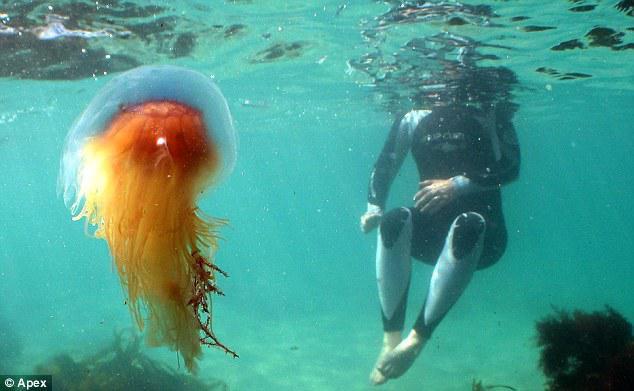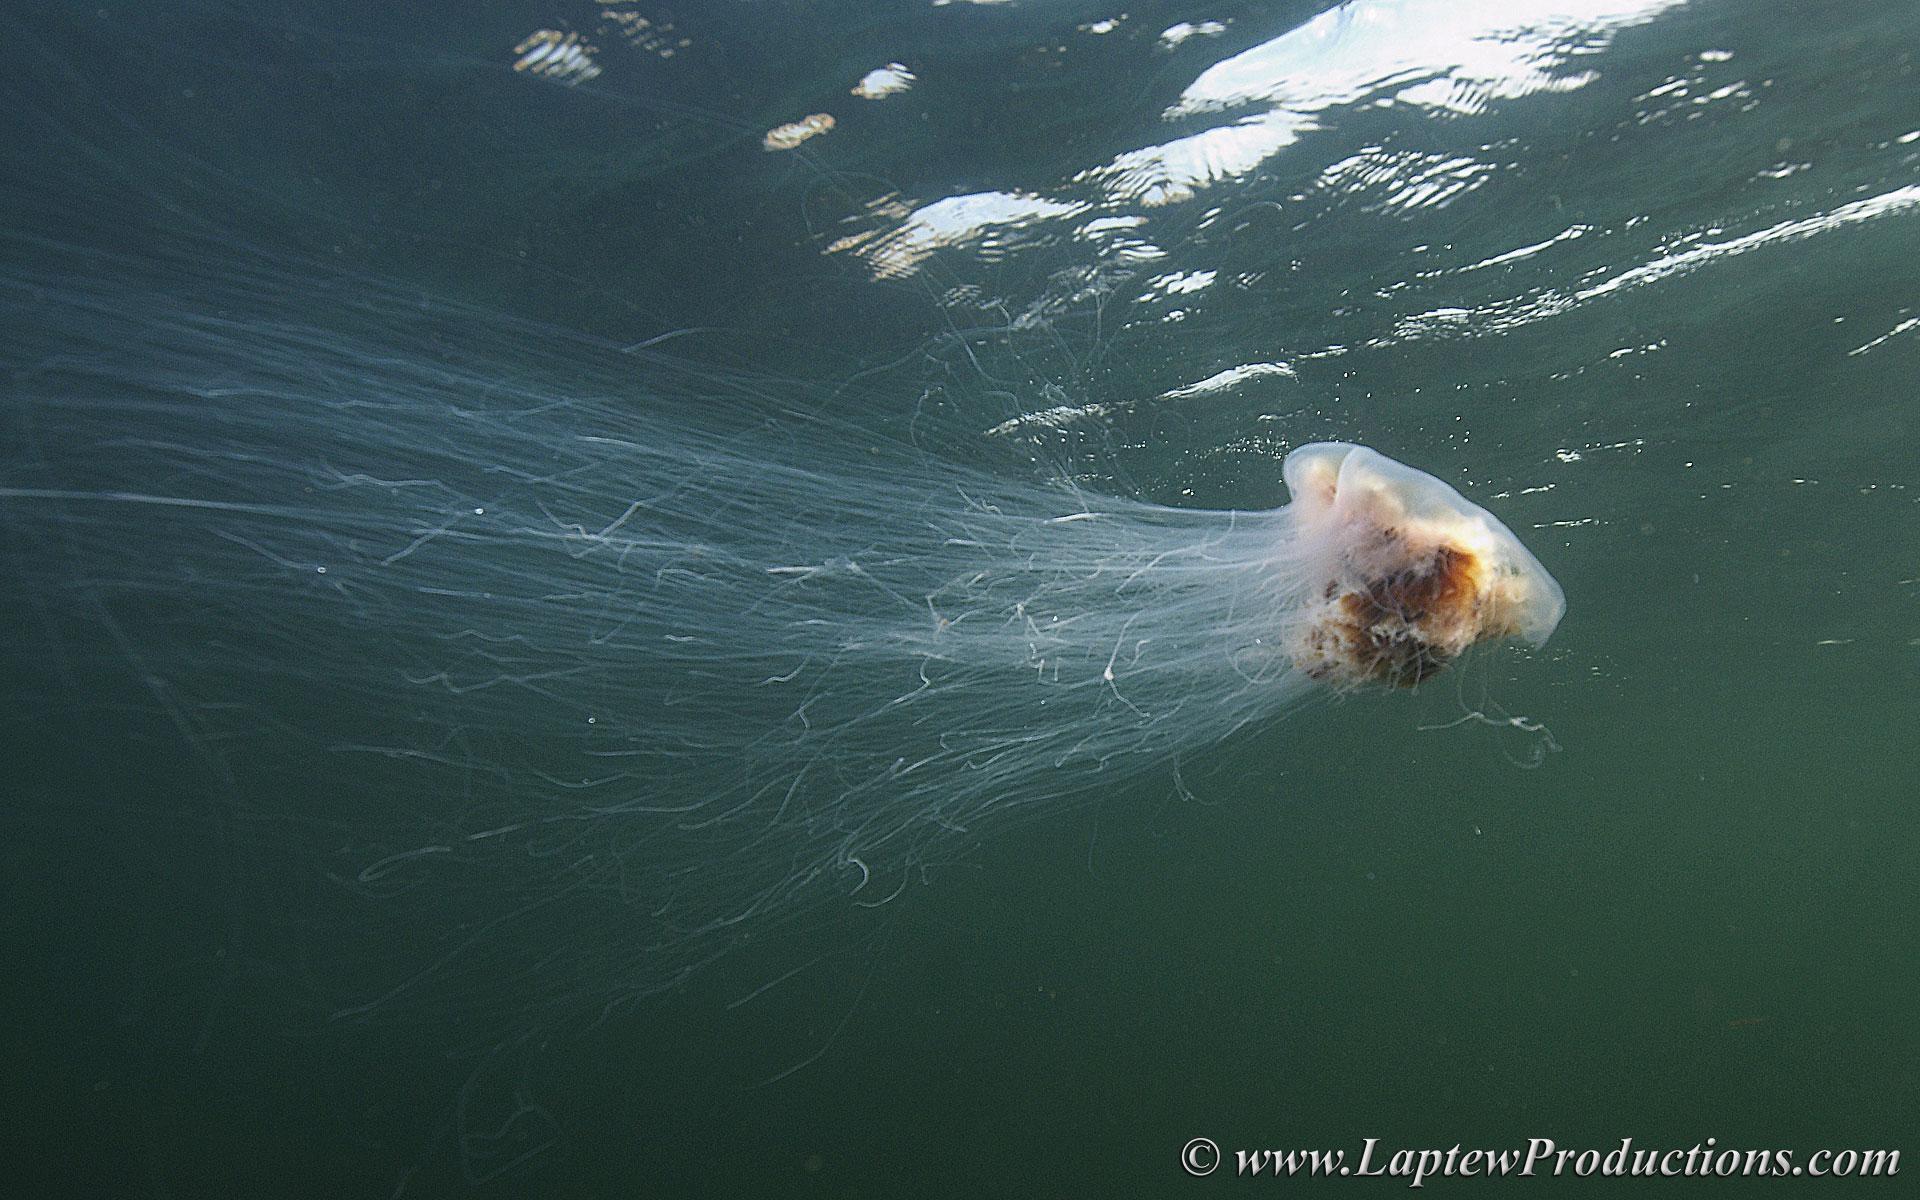The first image is the image on the left, the second image is the image on the right. For the images shown, is this caption "One scuba diver is to the right of a jelly fish." true? Answer yes or no. Yes. 